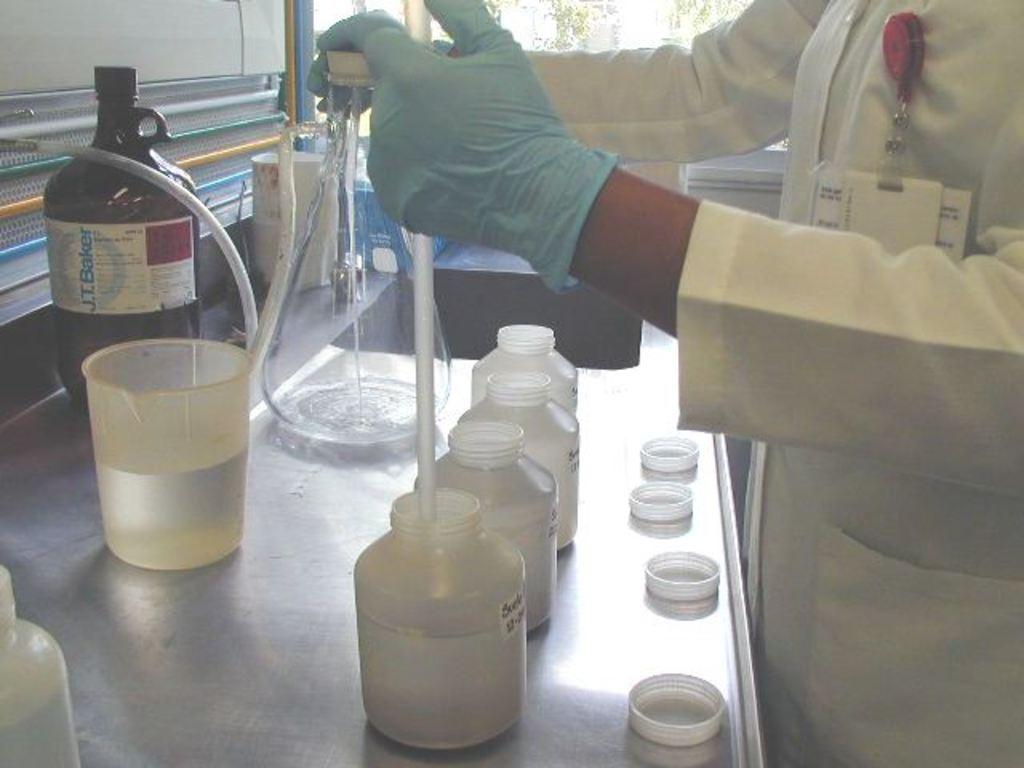Who produced the bottle on the counter?
Provide a short and direct response. J.t. baker. 